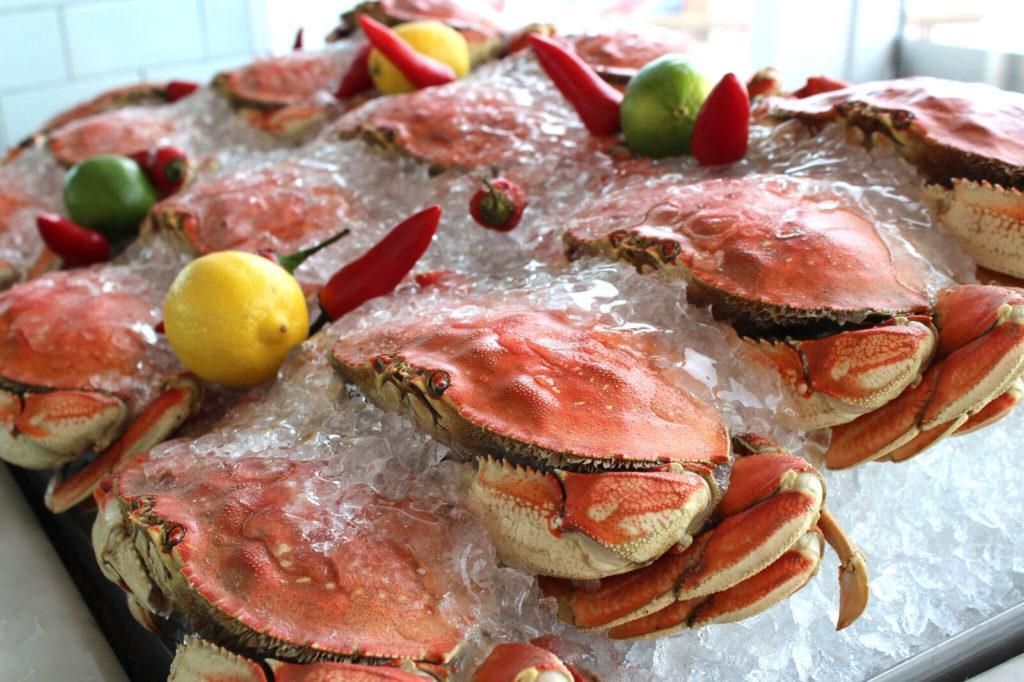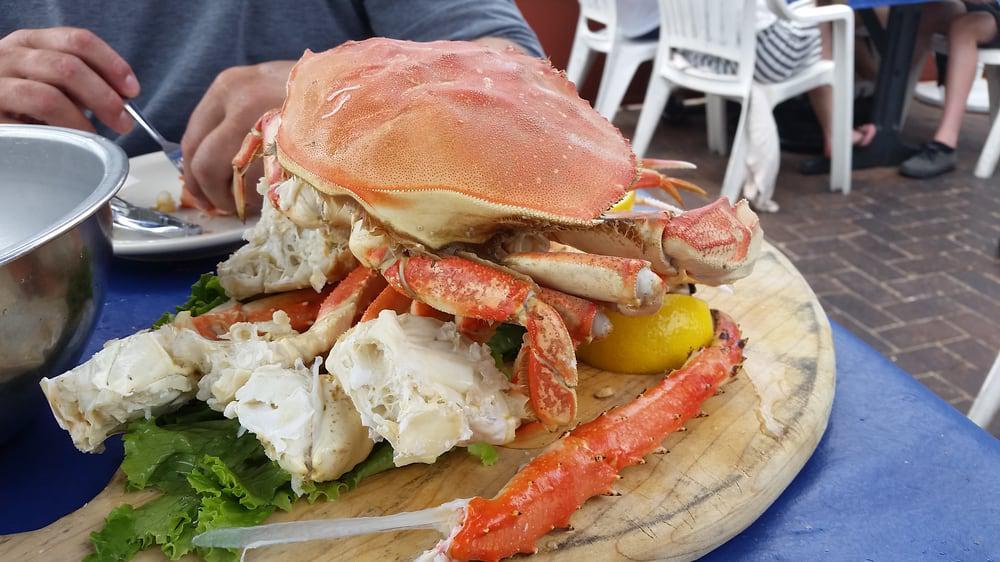The first image is the image on the left, the second image is the image on the right. Analyze the images presented: Is the assertion "There is sauce next to the crab meat." valid? Answer yes or no. No. The first image is the image on the left, the second image is the image on the right. Examine the images to the left and right. Is the description "There are at least two lemons and two lime to season crab legs." accurate? Answer yes or no. Yes. 